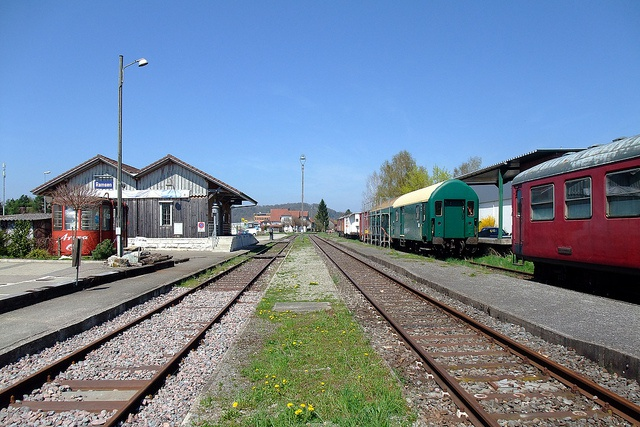Describe the objects in this image and their specific colors. I can see train in gray, maroon, black, and blue tones, train in gray, teal, black, and beige tones, and car in gray, black, navy, and blue tones in this image. 